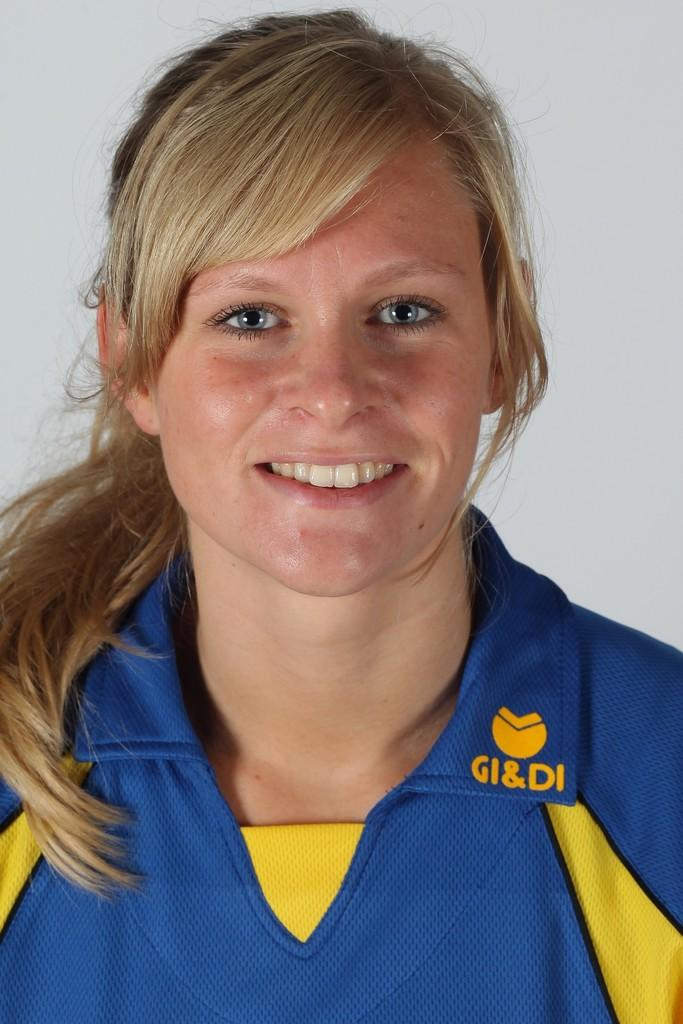<image>
Describe the image concisely. a lady with the letters GI&DI on her outfit 